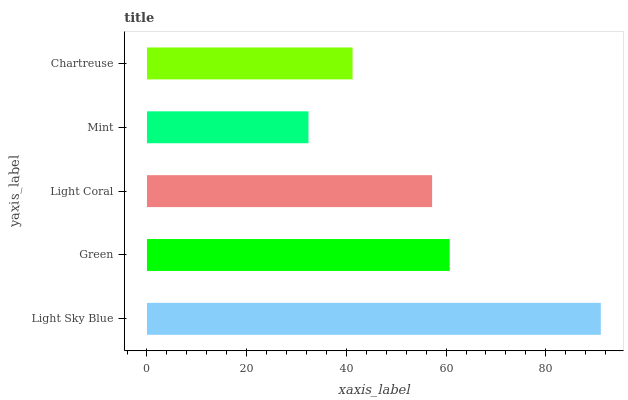Is Mint the minimum?
Answer yes or no. Yes. Is Light Sky Blue the maximum?
Answer yes or no. Yes. Is Green the minimum?
Answer yes or no. No. Is Green the maximum?
Answer yes or no. No. Is Light Sky Blue greater than Green?
Answer yes or no. Yes. Is Green less than Light Sky Blue?
Answer yes or no. Yes. Is Green greater than Light Sky Blue?
Answer yes or no. No. Is Light Sky Blue less than Green?
Answer yes or no. No. Is Light Coral the high median?
Answer yes or no. Yes. Is Light Coral the low median?
Answer yes or no. Yes. Is Mint the high median?
Answer yes or no. No. Is Chartreuse the low median?
Answer yes or no. No. 